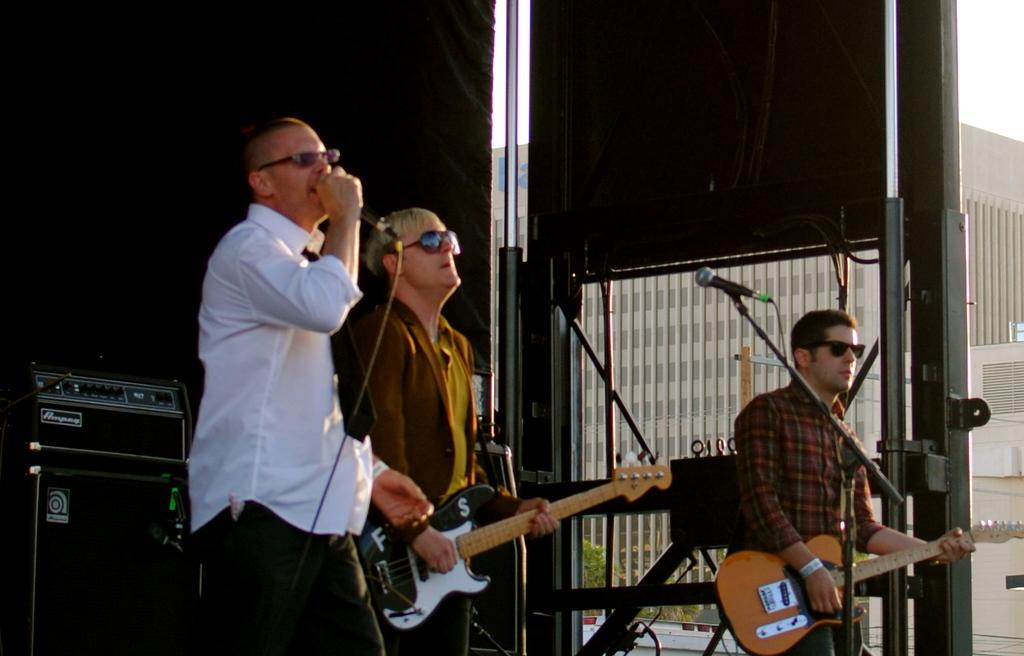What type of event is taking place in the image? The image is from a musical concert. What instruments are being played by the people in the image? Two people are playing guitars in the image. What is the person with the microphone doing? One person is singing with a microphone in the image. What can be seen in the background of the image? There are black boxes in the background of the image. How does the person with the microphone get into trouble during the concert? There is no indication in the image that the person with the microphone is getting into trouble or experiencing any issues. 